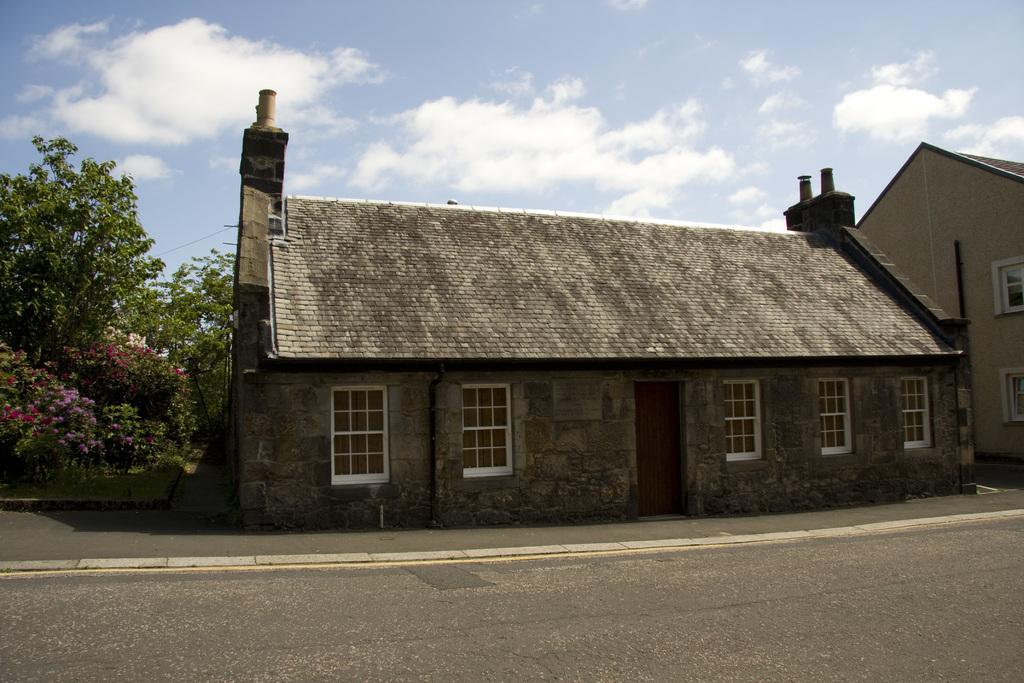What is in the foreground of the image? There is a road in the foreground of the image. What can be seen in the middle of the image? There are two houses in the middle of the image. What type of vegetation is present in the image? Flowers are present in the image. What else can be seen in the image besides the houses and flowers? Trees are visible in the image. What is visible at the top of the image? The sky is visible at the top of the image. Can you describe the sky in the image? The sky is visible at the top of the image, and there is a cloud in the sky. What type of locket is the son holding in the image? There is no son or locket present in the image. Can you tell me how many trains are visible in the image? There are no trains visible in the image. 